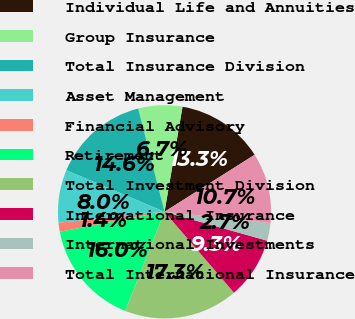Convert chart. <chart><loc_0><loc_0><loc_500><loc_500><pie_chart><fcel>Individual Life and Annuities<fcel>Group Insurance<fcel>Total Insurance Division<fcel>Asset Management<fcel>Financial Advisory<fcel>Retirement<fcel>Total Investment Division<fcel>International Insurance<fcel>International Investments<fcel>Total International Insurance<nl><fcel>13.32%<fcel>6.68%<fcel>14.65%<fcel>8.01%<fcel>1.36%<fcel>15.98%<fcel>17.31%<fcel>9.34%<fcel>2.69%<fcel>10.66%<nl></chart> 